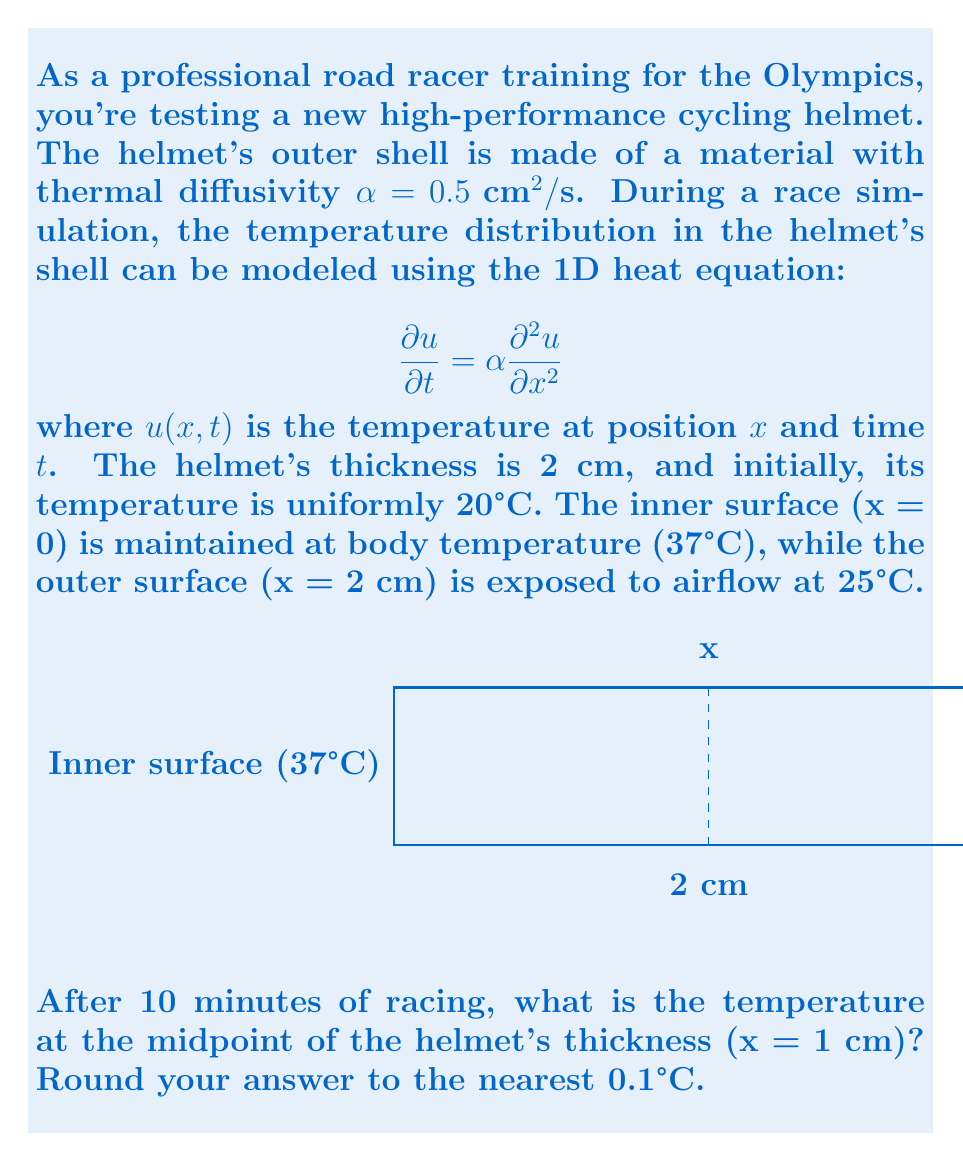Provide a solution to this math problem. To solve this problem, we need to use the solution to the 1D heat equation with mixed boundary conditions. The general solution is given by:

$$u(x,t) = A + Bx + \sum_{n=1}^{\infty} C_n e^{-\alpha \lambda_n^2 t} \sin(\lambda_n x)$$

where $A$ and $B$ are constants determined by the boundary conditions, and $\lambda_n$ are the eigenvalues.

Step 1: Determine the steady-state solution
The steady-state solution is given by $A + Bx$. Using the boundary conditions:
$u(0,t) = 37$ and $u(2,t) = 25$, we get:
$A = 37$ and $B = -6$

So, the steady-state solution is: $u_s(x) = 37 - 6x$

Step 2: Find the eigenvalues
The eigenvalues are given by $\lambda_n = \frac{n\pi}{2}$ for $n = 1, 2, 3, ...$

Step 3: Determine the coefficients $C_n$
$C_n = \frac{2}{L} \int_0^L [f(x) - u_s(x)] \sin(\lambda_n x) dx$

where $f(x) = 20$ (initial condition) and $L = 2$ cm.

$C_n = \frac{2}{2} \int_0^2 [20 - (37 - 6x)] \sin(\frac{n\pi}{2}x) dx$

After integration:
$C_n = \frac{24}{n\pi} [\cos(n\pi) - 1]$ for odd $n$, and $C_n = 0$ for even $n$

Step 4: Write the full solution
$$u(x,t) = 37 - 6x + \sum_{n=1,3,5,...}^{\infty} \frac{24}{n\pi} [\cos(n\pi) - 1] e^{-0.5 (\frac{n\pi}{2})^2 t} \sin(\frac{n\pi}{2}x)$$

Step 5: Calculate the temperature at x = 1 cm and t = 10 minutes = 600 seconds
Evaluate the series for the first few terms (n = 1, 3, 5) as the higher terms quickly become negligible:

$$u(1,600) = 37 - 6(1) + \frac{24}{\pi} [-2 e^{-0.5 (\frac{\pi}{2})^2 600} \sin(\frac{\pi}{2})] + \frac{24}{3\pi} [-2 e^{-0.5 (\frac{3\pi}{2})^2 600} \sin(\frac{3\pi}{2})] + \frac{24}{5\pi} [-2 e^{-0.5 (\frac{5\pi}{2})^2 600} \sin(\frac{5\pi}{2})]$$

Evaluating this expression numerically gives approximately 30.9°C.
Answer: 31.0°C 